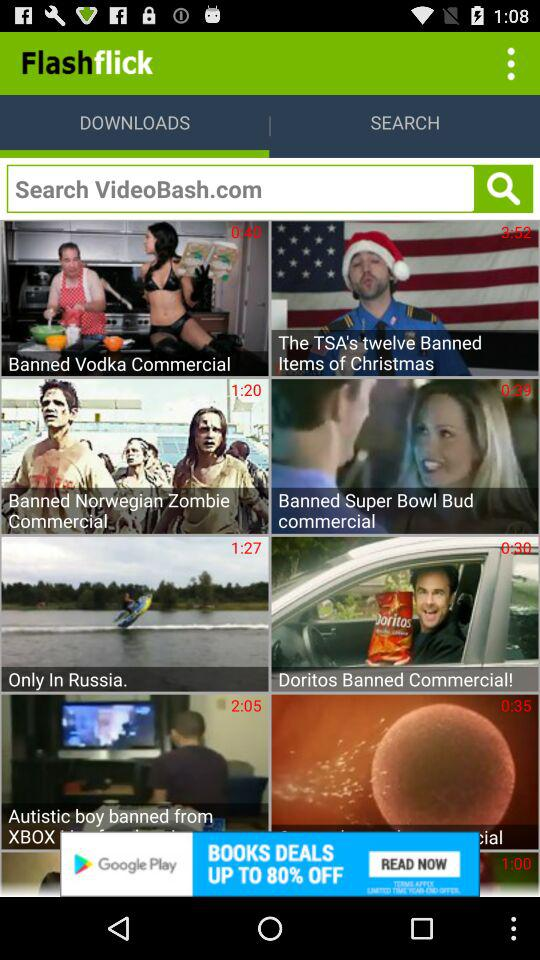What are the different downloads? The different downloads are "Banned Vodka Commercial", "The TSA's twelve Banned Items of Christmas", "Banned Norwegian Zombie Commercial", "Banned Super Bowl Bud commercial", "Only In Russia." and "Doritos Banned Commercial!". 